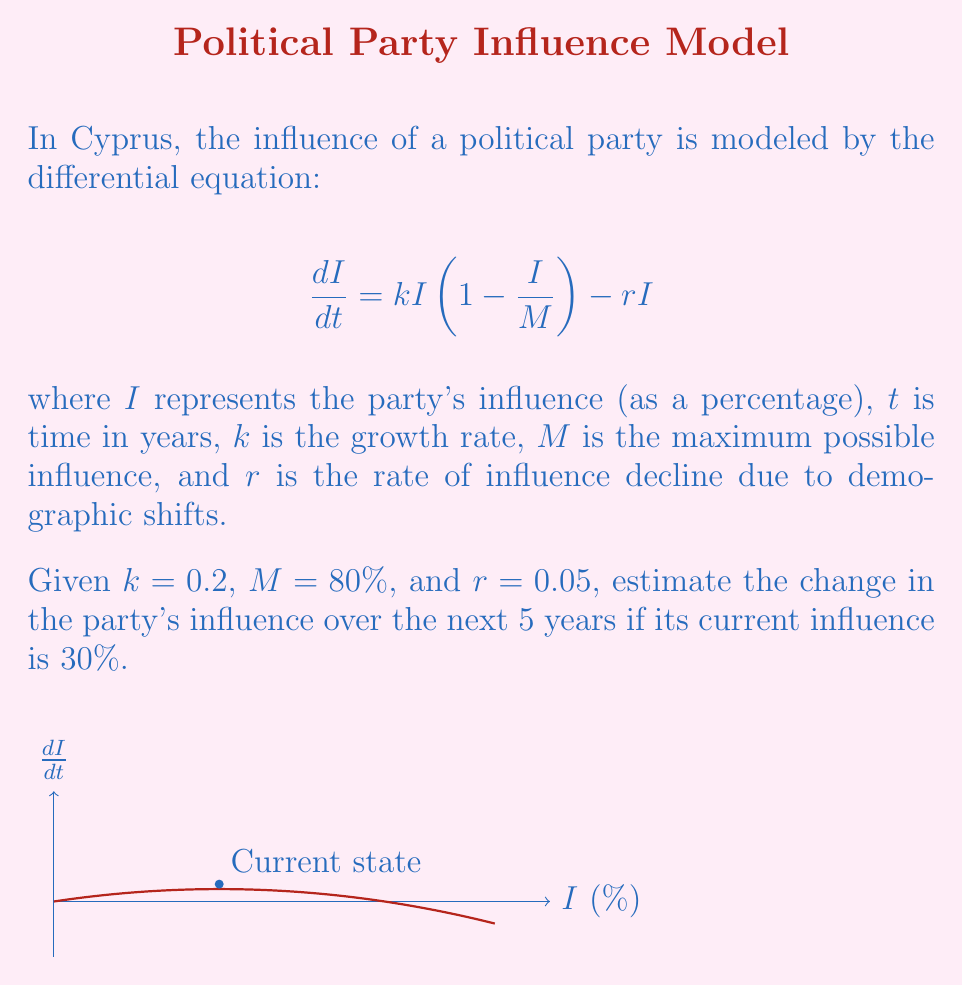Teach me how to tackle this problem. Let's approach this step-by-step:

1) We start with the differential equation:
   $$\frac{dI}{dt} = kI(1 - \frac{I}{M}) - rI$$

2) Substitute the given values:
   $$\frac{dI}{dt} = 0.2I(1 - \frac{I}{80}) - 0.05I$$

3) To estimate the change over 5 years, we can use Euler's method with a large step size (h = 5):
   $$I_{new} = I_{old} + h \cdot \frac{dI}{dt}$$

4) Calculate $\frac{dI}{dt}$ at the current state (I = 30%):
   $$\frac{dI}{dt} = 0.2(30)(1 - \frac{30}{80}) - 0.05(30) = 3.375$$

5) Apply Euler's method:
   $$I_{new} = 30 + 5 \cdot 3.375 = 46.875\%$$

6) Calculate the change in influence:
   $$\Delta I = I_{new} - I_{old} = 46.875\% - 30\% = 16.875\%$$

Therefore, the estimated change in the party's influence over the next 5 years is an increase of approximately 16.875%.
Answer: 16.875% increase 